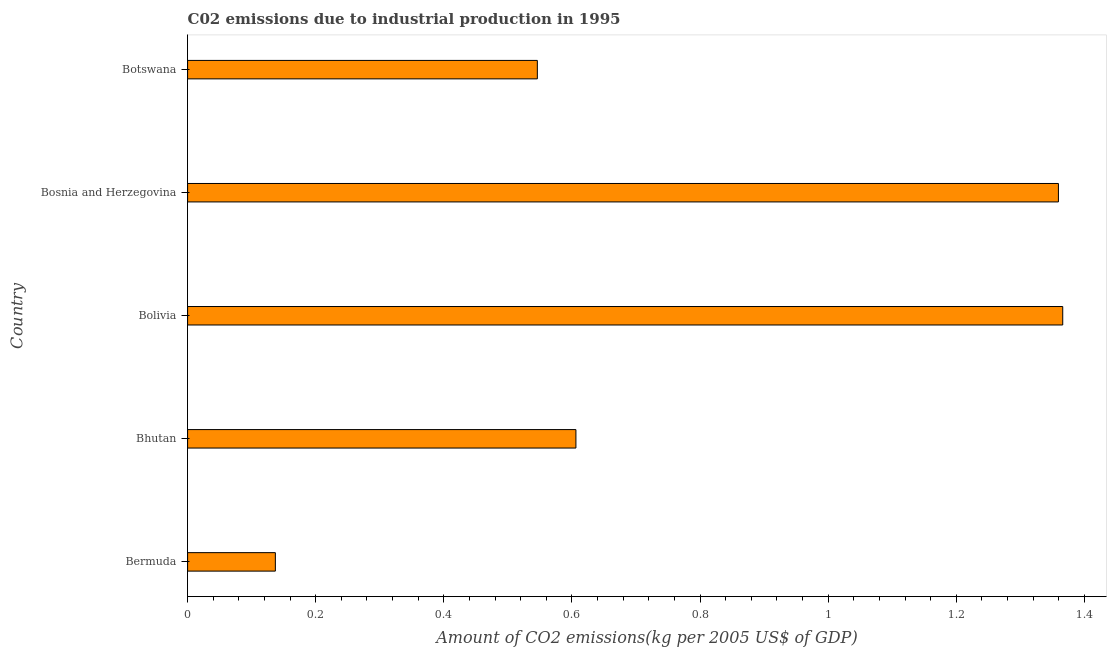What is the title of the graph?
Offer a very short reply. C02 emissions due to industrial production in 1995. What is the label or title of the X-axis?
Keep it short and to the point. Amount of CO2 emissions(kg per 2005 US$ of GDP). What is the label or title of the Y-axis?
Make the answer very short. Country. What is the amount of co2 emissions in Bermuda?
Offer a very short reply. 0.14. Across all countries, what is the maximum amount of co2 emissions?
Provide a succinct answer. 1.37. Across all countries, what is the minimum amount of co2 emissions?
Ensure brevity in your answer.  0.14. In which country was the amount of co2 emissions minimum?
Keep it short and to the point. Bermuda. What is the sum of the amount of co2 emissions?
Ensure brevity in your answer.  4.01. What is the difference between the amount of co2 emissions in Bermuda and Bolivia?
Your answer should be compact. -1.23. What is the average amount of co2 emissions per country?
Provide a short and direct response. 0.8. What is the median amount of co2 emissions?
Provide a succinct answer. 0.61. Is the difference between the amount of co2 emissions in Bolivia and Bosnia and Herzegovina greater than the difference between any two countries?
Ensure brevity in your answer.  No. What is the difference between the highest and the second highest amount of co2 emissions?
Offer a terse response. 0.01. What is the difference between the highest and the lowest amount of co2 emissions?
Your answer should be very brief. 1.23. In how many countries, is the amount of co2 emissions greater than the average amount of co2 emissions taken over all countries?
Your response must be concise. 2. How many bars are there?
Offer a very short reply. 5. Are all the bars in the graph horizontal?
Provide a short and direct response. Yes. How many countries are there in the graph?
Your answer should be compact. 5. What is the Amount of CO2 emissions(kg per 2005 US$ of GDP) in Bermuda?
Keep it short and to the point. 0.14. What is the Amount of CO2 emissions(kg per 2005 US$ of GDP) of Bhutan?
Provide a succinct answer. 0.61. What is the Amount of CO2 emissions(kg per 2005 US$ of GDP) in Bolivia?
Keep it short and to the point. 1.37. What is the Amount of CO2 emissions(kg per 2005 US$ of GDP) in Bosnia and Herzegovina?
Provide a succinct answer. 1.36. What is the Amount of CO2 emissions(kg per 2005 US$ of GDP) of Botswana?
Provide a succinct answer. 0.55. What is the difference between the Amount of CO2 emissions(kg per 2005 US$ of GDP) in Bermuda and Bhutan?
Provide a short and direct response. -0.47. What is the difference between the Amount of CO2 emissions(kg per 2005 US$ of GDP) in Bermuda and Bolivia?
Your answer should be compact. -1.23. What is the difference between the Amount of CO2 emissions(kg per 2005 US$ of GDP) in Bermuda and Bosnia and Herzegovina?
Offer a very short reply. -1.22. What is the difference between the Amount of CO2 emissions(kg per 2005 US$ of GDP) in Bermuda and Botswana?
Give a very brief answer. -0.41. What is the difference between the Amount of CO2 emissions(kg per 2005 US$ of GDP) in Bhutan and Bolivia?
Keep it short and to the point. -0.76. What is the difference between the Amount of CO2 emissions(kg per 2005 US$ of GDP) in Bhutan and Bosnia and Herzegovina?
Keep it short and to the point. -0.75. What is the difference between the Amount of CO2 emissions(kg per 2005 US$ of GDP) in Bhutan and Botswana?
Your response must be concise. 0.06. What is the difference between the Amount of CO2 emissions(kg per 2005 US$ of GDP) in Bolivia and Bosnia and Herzegovina?
Provide a short and direct response. 0.01. What is the difference between the Amount of CO2 emissions(kg per 2005 US$ of GDP) in Bolivia and Botswana?
Keep it short and to the point. 0.82. What is the difference between the Amount of CO2 emissions(kg per 2005 US$ of GDP) in Bosnia and Herzegovina and Botswana?
Offer a terse response. 0.81. What is the ratio of the Amount of CO2 emissions(kg per 2005 US$ of GDP) in Bermuda to that in Bhutan?
Your answer should be very brief. 0.23. What is the ratio of the Amount of CO2 emissions(kg per 2005 US$ of GDP) in Bermuda to that in Bolivia?
Offer a terse response. 0.1. What is the ratio of the Amount of CO2 emissions(kg per 2005 US$ of GDP) in Bermuda to that in Bosnia and Herzegovina?
Provide a succinct answer. 0.1. What is the ratio of the Amount of CO2 emissions(kg per 2005 US$ of GDP) in Bermuda to that in Botswana?
Provide a succinct answer. 0.25. What is the ratio of the Amount of CO2 emissions(kg per 2005 US$ of GDP) in Bhutan to that in Bolivia?
Make the answer very short. 0.44. What is the ratio of the Amount of CO2 emissions(kg per 2005 US$ of GDP) in Bhutan to that in Bosnia and Herzegovina?
Provide a succinct answer. 0.45. What is the ratio of the Amount of CO2 emissions(kg per 2005 US$ of GDP) in Bhutan to that in Botswana?
Make the answer very short. 1.11. What is the ratio of the Amount of CO2 emissions(kg per 2005 US$ of GDP) in Bolivia to that in Bosnia and Herzegovina?
Give a very brief answer. 1. What is the ratio of the Amount of CO2 emissions(kg per 2005 US$ of GDP) in Bolivia to that in Botswana?
Give a very brief answer. 2.5. What is the ratio of the Amount of CO2 emissions(kg per 2005 US$ of GDP) in Bosnia and Herzegovina to that in Botswana?
Ensure brevity in your answer.  2.49. 